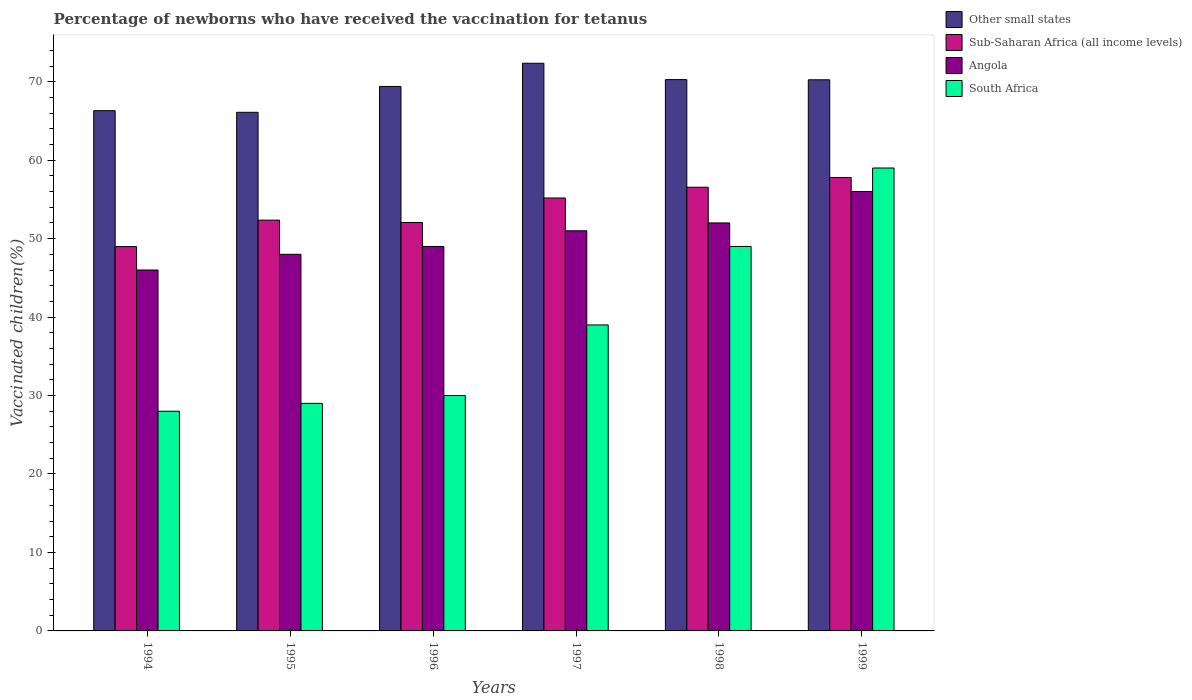How many bars are there on the 2nd tick from the right?
Offer a very short reply. 4. What is the label of the 3rd group of bars from the left?
Your answer should be very brief. 1996. In how many cases, is the number of bars for a given year not equal to the number of legend labels?
Offer a very short reply. 0. What is the percentage of vaccinated children in Sub-Saharan Africa (all income levels) in 1995?
Keep it short and to the point. 52.35. Across all years, what is the maximum percentage of vaccinated children in Angola?
Your response must be concise. 56. Across all years, what is the minimum percentage of vaccinated children in Sub-Saharan Africa (all income levels)?
Keep it short and to the point. 48.98. In which year was the percentage of vaccinated children in Other small states minimum?
Your answer should be compact. 1995. What is the total percentage of vaccinated children in South Africa in the graph?
Offer a very short reply. 234. What is the difference between the percentage of vaccinated children in Sub-Saharan Africa (all income levels) in 1996 and that in 1998?
Your answer should be compact. -4.5. What is the difference between the percentage of vaccinated children in South Africa in 1999 and the percentage of vaccinated children in Angola in 1995?
Your answer should be compact. 11. In the year 1996, what is the difference between the percentage of vaccinated children in South Africa and percentage of vaccinated children in Sub-Saharan Africa (all income levels)?
Offer a very short reply. -22.05. What is the ratio of the percentage of vaccinated children in South Africa in 1997 to that in 1999?
Your answer should be compact. 0.66. Is the difference between the percentage of vaccinated children in South Africa in 1997 and 1998 greater than the difference between the percentage of vaccinated children in Sub-Saharan Africa (all income levels) in 1997 and 1998?
Provide a succinct answer. No. What is the difference between the highest and the second highest percentage of vaccinated children in Other small states?
Offer a very short reply. 2.08. What is the difference between the highest and the lowest percentage of vaccinated children in Other small states?
Offer a very short reply. 6.25. Is the sum of the percentage of vaccinated children in Sub-Saharan Africa (all income levels) in 1998 and 1999 greater than the maximum percentage of vaccinated children in Other small states across all years?
Offer a very short reply. Yes. What does the 2nd bar from the left in 1995 represents?
Your answer should be very brief. Sub-Saharan Africa (all income levels). What does the 2nd bar from the right in 1998 represents?
Your response must be concise. Angola. Is it the case that in every year, the sum of the percentage of vaccinated children in South Africa and percentage of vaccinated children in Angola is greater than the percentage of vaccinated children in Sub-Saharan Africa (all income levels)?
Offer a very short reply. Yes. Does the graph contain any zero values?
Provide a succinct answer. No. Where does the legend appear in the graph?
Provide a succinct answer. Top right. What is the title of the graph?
Your answer should be very brief. Percentage of newborns who have received the vaccination for tetanus. Does "South Asia" appear as one of the legend labels in the graph?
Keep it short and to the point. No. What is the label or title of the X-axis?
Ensure brevity in your answer.  Years. What is the label or title of the Y-axis?
Your response must be concise. Vaccinated children(%). What is the Vaccinated children(%) of Other small states in 1994?
Give a very brief answer. 66.31. What is the Vaccinated children(%) of Sub-Saharan Africa (all income levels) in 1994?
Ensure brevity in your answer.  48.98. What is the Vaccinated children(%) of South Africa in 1994?
Your answer should be very brief. 28. What is the Vaccinated children(%) in Other small states in 1995?
Make the answer very short. 66.1. What is the Vaccinated children(%) in Sub-Saharan Africa (all income levels) in 1995?
Provide a short and direct response. 52.35. What is the Vaccinated children(%) in South Africa in 1995?
Your answer should be very brief. 29. What is the Vaccinated children(%) of Other small states in 1996?
Make the answer very short. 69.39. What is the Vaccinated children(%) of Sub-Saharan Africa (all income levels) in 1996?
Offer a terse response. 52.05. What is the Vaccinated children(%) in Angola in 1996?
Your answer should be very brief. 49. What is the Vaccinated children(%) of South Africa in 1996?
Make the answer very short. 30. What is the Vaccinated children(%) in Other small states in 1997?
Your answer should be compact. 72.35. What is the Vaccinated children(%) of Sub-Saharan Africa (all income levels) in 1997?
Ensure brevity in your answer.  55.18. What is the Vaccinated children(%) of Other small states in 1998?
Provide a short and direct response. 70.27. What is the Vaccinated children(%) in Sub-Saharan Africa (all income levels) in 1998?
Your answer should be compact. 56.55. What is the Vaccinated children(%) of South Africa in 1998?
Make the answer very short. 49. What is the Vaccinated children(%) of Other small states in 1999?
Your answer should be very brief. 70.24. What is the Vaccinated children(%) of Sub-Saharan Africa (all income levels) in 1999?
Your answer should be compact. 57.79. What is the Vaccinated children(%) in Angola in 1999?
Keep it short and to the point. 56. Across all years, what is the maximum Vaccinated children(%) of Other small states?
Provide a succinct answer. 72.35. Across all years, what is the maximum Vaccinated children(%) in Sub-Saharan Africa (all income levels)?
Provide a short and direct response. 57.79. Across all years, what is the maximum Vaccinated children(%) in Angola?
Give a very brief answer. 56. Across all years, what is the minimum Vaccinated children(%) in Other small states?
Provide a short and direct response. 66.1. Across all years, what is the minimum Vaccinated children(%) in Sub-Saharan Africa (all income levels)?
Provide a short and direct response. 48.98. Across all years, what is the minimum Vaccinated children(%) in Angola?
Give a very brief answer. 46. What is the total Vaccinated children(%) in Other small states in the graph?
Make the answer very short. 414.66. What is the total Vaccinated children(%) of Sub-Saharan Africa (all income levels) in the graph?
Give a very brief answer. 322.91. What is the total Vaccinated children(%) in Angola in the graph?
Keep it short and to the point. 302. What is the total Vaccinated children(%) in South Africa in the graph?
Make the answer very short. 234. What is the difference between the Vaccinated children(%) in Other small states in 1994 and that in 1995?
Your answer should be compact. 0.21. What is the difference between the Vaccinated children(%) in Sub-Saharan Africa (all income levels) in 1994 and that in 1995?
Give a very brief answer. -3.37. What is the difference between the Vaccinated children(%) of Angola in 1994 and that in 1995?
Offer a terse response. -2. What is the difference between the Vaccinated children(%) in South Africa in 1994 and that in 1995?
Offer a terse response. -1. What is the difference between the Vaccinated children(%) of Other small states in 1994 and that in 1996?
Make the answer very short. -3.08. What is the difference between the Vaccinated children(%) in Sub-Saharan Africa (all income levels) in 1994 and that in 1996?
Your answer should be compact. -3.07. What is the difference between the Vaccinated children(%) in South Africa in 1994 and that in 1996?
Provide a succinct answer. -2. What is the difference between the Vaccinated children(%) of Other small states in 1994 and that in 1997?
Provide a succinct answer. -6.04. What is the difference between the Vaccinated children(%) in Sub-Saharan Africa (all income levels) in 1994 and that in 1997?
Provide a succinct answer. -6.2. What is the difference between the Vaccinated children(%) in Other small states in 1994 and that in 1998?
Provide a short and direct response. -3.96. What is the difference between the Vaccinated children(%) in Sub-Saharan Africa (all income levels) in 1994 and that in 1998?
Your answer should be compact. -7.57. What is the difference between the Vaccinated children(%) in Angola in 1994 and that in 1998?
Offer a terse response. -6. What is the difference between the Vaccinated children(%) in South Africa in 1994 and that in 1998?
Give a very brief answer. -21. What is the difference between the Vaccinated children(%) in Other small states in 1994 and that in 1999?
Your answer should be very brief. -3.94. What is the difference between the Vaccinated children(%) in Sub-Saharan Africa (all income levels) in 1994 and that in 1999?
Provide a short and direct response. -8.81. What is the difference between the Vaccinated children(%) in Angola in 1994 and that in 1999?
Your answer should be compact. -10. What is the difference between the Vaccinated children(%) in South Africa in 1994 and that in 1999?
Offer a very short reply. -31. What is the difference between the Vaccinated children(%) in Other small states in 1995 and that in 1996?
Offer a terse response. -3.29. What is the difference between the Vaccinated children(%) of Sub-Saharan Africa (all income levels) in 1995 and that in 1996?
Keep it short and to the point. 0.3. What is the difference between the Vaccinated children(%) in Angola in 1995 and that in 1996?
Your answer should be compact. -1. What is the difference between the Vaccinated children(%) of South Africa in 1995 and that in 1996?
Keep it short and to the point. -1. What is the difference between the Vaccinated children(%) in Other small states in 1995 and that in 1997?
Your response must be concise. -6.25. What is the difference between the Vaccinated children(%) in Sub-Saharan Africa (all income levels) in 1995 and that in 1997?
Offer a terse response. -2.82. What is the difference between the Vaccinated children(%) in Angola in 1995 and that in 1997?
Keep it short and to the point. -3. What is the difference between the Vaccinated children(%) in Other small states in 1995 and that in 1998?
Offer a very short reply. -4.17. What is the difference between the Vaccinated children(%) in Sub-Saharan Africa (all income levels) in 1995 and that in 1998?
Give a very brief answer. -4.2. What is the difference between the Vaccinated children(%) of Angola in 1995 and that in 1998?
Your answer should be very brief. -4. What is the difference between the Vaccinated children(%) of South Africa in 1995 and that in 1998?
Your answer should be very brief. -20. What is the difference between the Vaccinated children(%) of Other small states in 1995 and that in 1999?
Provide a succinct answer. -4.14. What is the difference between the Vaccinated children(%) of Sub-Saharan Africa (all income levels) in 1995 and that in 1999?
Your answer should be compact. -5.44. What is the difference between the Vaccinated children(%) in Other small states in 1996 and that in 1997?
Give a very brief answer. -2.96. What is the difference between the Vaccinated children(%) of Sub-Saharan Africa (all income levels) in 1996 and that in 1997?
Provide a short and direct response. -3.12. What is the difference between the Vaccinated children(%) in Angola in 1996 and that in 1997?
Your response must be concise. -2. What is the difference between the Vaccinated children(%) in Other small states in 1996 and that in 1998?
Keep it short and to the point. -0.87. What is the difference between the Vaccinated children(%) of Sub-Saharan Africa (all income levels) in 1996 and that in 1998?
Offer a terse response. -4.5. What is the difference between the Vaccinated children(%) of Angola in 1996 and that in 1998?
Provide a short and direct response. -3. What is the difference between the Vaccinated children(%) in South Africa in 1996 and that in 1998?
Provide a short and direct response. -19. What is the difference between the Vaccinated children(%) of Other small states in 1996 and that in 1999?
Make the answer very short. -0.85. What is the difference between the Vaccinated children(%) of Sub-Saharan Africa (all income levels) in 1996 and that in 1999?
Ensure brevity in your answer.  -5.74. What is the difference between the Vaccinated children(%) of South Africa in 1996 and that in 1999?
Provide a succinct answer. -29. What is the difference between the Vaccinated children(%) in Other small states in 1997 and that in 1998?
Keep it short and to the point. 2.08. What is the difference between the Vaccinated children(%) in Sub-Saharan Africa (all income levels) in 1997 and that in 1998?
Offer a very short reply. -1.37. What is the difference between the Vaccinated children(%) in Angola in 1997 and that in 1998?
Keep it short and to the point. -1. What is the difference between the Vaccinated children(%) of South Africa in 1997 and that in 1998?
Keep it short and to the point. -10. What is the difference between the Vaccinated children(%) in Other small states in 1997 and that in 1999?
Provide a short and direct response. 2.11. What is the difference between the Vaccinated children(%) of Sub-Saharan Africa (all income levels) in 1997 and that in 1999?
Your answer should be very brief. -2.62. What is the difference between the Vaccinated children(%) in Angola in 1997 and that in 1999?
Your answer should be compact. -5. What is the difference between the Vaccinated children(%) in South Africa in 1997 and that in 1999?
Your answer should be very brief. -20. What is the difference between the Vaccinated children(%) in Other small states in 1998 and that in 1999?
Give a very brief answer. 0.02. What is the difference between the Vaccinated children(%) in Sub-Saharan Africa (all income levels) in 1998 and that in 1999?
Make the answer very short. -1.24. What is the difference between the Vaccinated children(%) of Angola in 1998 and that in 1999?
Keep it short and to the point. -4. What is the difference between the Vaccinated children(%) of South Africa in 1998 and that in 1999?
Provide a succinct answer. -10. What is the difference between the Vaccinated children(%) of Other small states in 1994 and the Vaccinated children(%) of Sub-Saharan Africa (all income levels) in 1995?
Provide a short and direct response. 13.96. What is the difference between the Vaccinated children(%) of Other small states in 1994 and the Vaccinated children(%) of Angola in 1995?
Your answer should be very brief. 18.31. What is the difference between the Vaccinated children(%) in Other small states in 1994 and the Vaccinated children(%) in South Africa in 1995?
Give a very brief answer. 37.31. What is the difference between the Vaccinated children(%) of Sub-Saharan Africa (all income levels) in 1994 and the Vaccinated children(%) of Angola in 1995?
Your answer should be very brief. 0.98. What is the difference between the Vaccinated children(%) in Sub-Saharan Africa (all income levels) in 1994 and the Vaccinated children(%) in South Africa in 1995?
Provide a short and direct response. 19.98. What is the difference between the Vaccinated children(%) in Angola in 1994 and the Vaccinated children(%) in South Africa in 1995?
Make the answer very short. 17. What is the difference between the Vaccinated children(%) of Other small states in 1994 and the Vaccinated children(%) of Sub-Saharan Africa (all income levels) in 1996?
Ensure brevity in your answer.  14.25. What is the difference between the Vaccinated children(%) in Other small states in 1994 and the Vaccinated children(%) in Angola in 1996?
Your answer should be compact. 17.31. What is the difference between the Vaccinated children(%) in Other small states in 1994 and the Vaccinated children(%) in South Africa in 1996?
Your response must be concise. 36.31. What is the difference between the Vaccinated children(%) in Sub-Saharan Africa (all income levels) in 1994 and the Vaccinated children(%) in Angola in 1996?
Ensure brevity in your answer.  -0.02. What is the difference between the Vaccinated children(%) in Sub-Saharan Africa (all income levels) in 1994 and the Vaccinated children(%) in South Africa in 1996?
Give a very brief answer. 18.98. What is the difference between the Vaccinated children(%) of Other small states in 1994 and the Vaccinated children(%) of Sub-Saharan Africa (all income levels) in 1997?
Your response must be concise. 11.13. What is the difference between the Vaccinated children(%) in Other small states in 1994 and the Vaccinated children(%) in Angola in 1997?
Your answer should be compact. 15.31. What is the difference between the Vaccinated children(%) in Other small states in 1994 and the Vaccinated children(%) in South Africa in 1997?
Ensure brevity in your answer.  27.31. What is the difference between the Vaccinated children(%) in Sub-Saharan Africa (all income levels) in 1994 and the Vaccinated children(%) in Angola in 1997?
Give a very brief answer. -2.02. What is the difference between the Vaccinated children(%) in Sub-Saharan Africa (all income levels) in 1994 and the Vaccinated children(%) in South Africa in 1997?
Provide a succinct answer. 9.98. What is the difference between the Vaccinated children(%) in Other small states in 1994 and the Vaccinated children(%) in Sub-Saharan Africa (all income levels) in 1998?
Offer a terse response. 9.76. What is the difference between the Vaccinated children(%) of Other small states in 1994 and the Vaccinated children(%) of Angola in 1998?
Ensure brevity in your answer.  14.31. What is the difference between the Vaccinated children(%) in Other small states in 1994 and the Vaccinated children(%) in South Africa in 1998?
Provide a short and direct response. 17.31. What is the difference between the Vaccinated children(%) in Sub-Saharan Africa (all income levels) in 1994 and the Vaccinated children(%) in Angola in 1998?
Make the answer very short. -3.02. What is the difference between the Vaccinated children(%) in Sub-Saharan Africa (all income levels) in 1994 and the Vaccinated children(%) in South Africa in 1998?
Provide a succinct answer. -0.02. What is the difference between the Vaccinated children(%) in Other small states in 1994 and the Vaccinated children(%) in Sub-Saharan Africa (all income levels) in 1999?
Provide a short and direct response. 8.52. What is the difference between the Vaccinated children(%) in Other small states in 1994 and the Vaccinated children(%) in Angola in 1999?
Offer a terse response. 10.31. What is the difference between the Vaccinated children(%) of Other small states in 1994 and the Vaccinated children(%) of South Africa in 1999?
Offer a terse response. 7.31. What is the difference between the Vaccinated children(%) of Sub-Saharan Africa (all income levels) in 1994 and the Vaccinated children(%) of Angola in 1999?
Provide a succinct answer. -7.02. What is the difference between the Vaccinated children(%) of Sub-Saharan Africa (all income levels) in 1994 and the Vaccinated children(%) of South Africa in 1999?
Offer a very short reply. -10.02. What is the difference between the Vaccinated children(%) of Other small states in 1995 and the Vaccinated children(%) of Sub-Saharan Africa (all income levels) in 1996?
Your answer should be compact. 14.04. What is the difference between the Vaccinated children(%) in Other small states in 1995 and the Vaccinated children(%) in Angola in 1996?
Your answer should be very brief. 17.1. What is the difference between the Vaccinated children(%) of Other small states in 1995 and the Vaccinated children(%) of South Africa in 1996?
Your answer should be compact. 36.1. What is the difference between the Vaccinated children(%) of Sub-Saharan Africa (all income levels) in 1995 and the Vaccinated children(%) of Angola in 1996?
Keep it short and to the point. 3.35. What is the difference between the Vaccinated children(%) in Sub-Saharan Africa (all income levels) in 1995 and the Vaccinated children(%) in South Africa in 1996?
Make the answer very short. 22.35. What is the difference between the Vaccinated children(%) of Angola in 1995 and the Vaccinated children(%) of South Africa in 1996?
Your response must be concise. 18. What is the difference between the Vaccinated children(%) of Other small states in 1995 and the Vaccinated children(%) of Sub-Saharan Africa (all income levels) in 1997?
Keep it short and to the point. 10.92. What is the difference between the Vaccinated children(%) in Other small states in 1995 and the Vaccinated children(%) in Angola in 1997?
Ensure brevity in your answer.  15.1. What is the difference between the Vaccinated children(%) in Other small states in 1995 and the Vaccinated children(%) in South Africa in 1997?
Give a very brief answer. 27.1. What is the difference between the Vaccinated children(%) in Sub-Saharan Africa (all income levels) in 1995 and the Vaccinated children(%) in Angola in 1997?
Provide a short and direct response. 1.35. What is the difference between the Vaccinated children(%) in Sub-Saharan Africa (all income levels) in 1995 and the Vaccinated children(%) in South Africa in 1997?
Keep it short and to the point. 13.35. What is the difference between the Vaccinated children(%) in Other small states in 1995 and the Vaccinated children(%) in Sub-Saharan Africa (all income levels) in 1998?
Keep it short and to the point. 9.55. What is the difference between the Vaccinated children(%) in Other small states in 1995 and the Vaccinated children(%) in Angola in 1998?
Provide a short and direct response. 14.1. What is the difference between the Vaccinated children(%) in Other small states in 1995 and the Vaccinated children(%) in South Africa in 1998?
Ensure brevity in your answer.  17.1. What is the difference between the Vaccinated children(%) of Sub-Saharan Africa (all income levels) in 1995 and the Vaccinated children(%) of Angola in 1998?
Your answer should be very brief. 0.35. What is the difference between the Vaccinated children(%) of Sub-Saharan Africa (all income levels) in 1995 and the Vaccinated children(%) of South Africa in 1998?
Your answer should be very brief. 3.35. What is the difference between the Vaccinated children(%) in Angola in 1995 and the Vaccinated children(%) in South Africa in 1998?
Keep it short and to the point. -1. What is the difference between the Vaccinated children(%) of Other small states in 1995 and the Vaccinated children(%) of Sub-Saharan Africa (all income levels) in 1999?
Make the answer very short. 8.31. What is the difference between the Vaccinated children(%) of Other small states in 1995 and the Vaccinated children(%) of Angola in 1999?
Offer a terse response. 10.1. What is the difference between the Vaccinated children(%) in Other small states in 1995 and the Vaccinated children(%) in South Africa in 1999?
Provide a succinct answer. 7.1. What is the difference between the Vaccinated children(%) in Sub-Saharan Africa (all income levels) in 1995 and the Vaccinated children(%) in Angola in 1999?
Provide a succinct answer. -3.65. What is the difference between the Vaccinated children(%) in Sub-Saharan Africa (all income levels) in 1995 and the Vaccinated children(%) in South Africa in 1999?
Offer a very short reply. -6.65. What is the difference between the Vaccinated children(%) in Angola in 1995 and the Vaccinated children(%) in South Africa in 1999?
Offer a very short reply. -11. What is the difference between the Vaccinated children(%) in Other small states in 1996 and the Vaccinated children(%) in Sub-Saharan Africa (all income levels) in 1997?
Provide a succinct answer. 14.21. What is the difference between the Vaccinated children(%) in Other small states in 1996 and the Vaccinated children(%) in Angola in 1997?
Your response must be concise. 18.39. What is the difference between the Vaccinated children(%) of Other small states in 1996 and the Vaccinated children(%) of South Africa in 1997?
Your answer should be compact. 30.39. What is the difference between the Vaccinated children(%) in Sub-Saharan Africa (all income levels) in 1996 and the Vaccinated children(%) in Angola in 1997?
Your answer should be compact. 1.05. What is the difference between the Vaccinated children(%) of Sub-Saharan Africa (all income levels) in 1996 and the Vaccinated children(%) of South Africa in 1997?
Your response must be concise. 13.05. What is the difference between the Vaccinated children(%) of Angola in 1996 and the Vaccinated children(%) of South Africa in 1997?
Give a very brief answer. 10. What is the difference between the Vaccinated children(%) of Other small states in 1996 and the Vaccinated children(%) of Sub-Saharan Africa (all income levels) in 1998?
Offer a very short reply. 12.84. What is the difference between the Vaccinated children(%) in Other small states in 1996 and the Vaccinated children(%) in Angola in 1998?
Provide a succinct answer. 17.39. What is the difference between the Vaccinated children(%) in Other small states in 1996 and the Vaccinated children(%) in South Africa in 1998?
Keep it short and to the point. 20.39. What is the difference between the Vaccinated children(%) of Sub-Saharan Africa (all income levels) in 1996 and the Vaccinated children(%) of Angola in 1998?
Ensure brevity in your answer.  0.05. What is the difference between the Vaccinated children(%) in Sub-Saharan Africa (all income levels) in 1996 and the Vaccinated children(%) in South Africa in 1998?
Provide a short and direct response. 3.05. What is the difference between the Vaccinated children(%) in Other small states in 1996 and the Vaccinated children(%) in Sub-Saharan Africa (all income levels) in 1999?
Keep it short and to the point. 11.6. What is the difference between the Vaccinated children(%) in Other small states in 1996 and the Vaccinated children(%) in Angola in 1999?
Make the answer very short. 13.39. What is the difference between the Vaccinated children(%) of Other small states in 1996 and the Vaccinated children(%) of South Africa in 1999?
Your answer should be very brief. 10.39. What is the difference between the Vaccinated children(%) in Sub-Saharan Africa (all income levels) in 1996 and the Vaccinated children(%) in Angola in 1999?
Offer a very short reply. -3.95. What is the difference between the Vaccinated children(%) in Sub-Saharan Africa (all income levels) in 1996 and the Vaccinated children(%) in South Africa in 1999?
Make the answer very short. -6.95. What is the difference between the Vaccinated children(%) in Other small states in 1997 and the Vaccinated children(%) in Sub-Saharan Africa (all income levels) in 1998?
Give a very brief answer. 15.8. What is the difference between the Vaccinated children(%) in Other small states in 1997 and the Vaccinated children(%) in Angola in 1998?
Offer a terse response. 20.35. What is the difference between the Vaccinated children(%) in Other small states in 1997 and the Vaccinated children(%) in South Africa in 1998?
Make the answer very short. 23.35. What is the difference between the Vaccinated children(%) of Sub-Saharan Africa (all income levels) in 1997 and the Vaccinated children(%) of Angola in 1998?
Ensure brevity in your answer.  3.18. What is the difference between the Vaccinated children(%) in Sub-Saharan Africa (all income levels) in 1997 and the Vaccinated children(%) in South Africa in 1998?
Keep it short and to the point. 6.18. What is the difference between the Vaccinated children(%) of Angola in 1997 and the Vaccinated children(%) of South Africa in 1998?
Keep it short and to the point. 2. What is the difference between the Vaccinated children(%) of Other small states in 1997 and the Vaccinated children(%) of Sub-Saharan Africa (all income levels) in 1999?
Keep it short and to the point. 14.56. What is the difference between the Vaccinated children(%) of Other small states in 1997 and the Vaccinated children(%) of Angola in 1999?
Offer a terse response. 16.35. What is the difference between the Vaccinated children(%) in Other small states in 1997 and the Vaccinated children(%) in South Africa in 1999?
Ensure brevity in your answer.  13.35. What is the difference between the Vaccinated children(%) in Sub-Saharan Africa (all income levels) in 1997 and the Vaccinated children(%) in Angola in 1999?
Make the answer very short. -0.82. What is the difference between the Vaccinated children(%) in Sub-Saharan Africa (all income levels) in 1997 and the Vaccinated children(%) in South Africa in 1999?
Provide a succinct answer. -3.82. What is the difference between the Vaccinated children(%) of Angola in 1997 and the Vaccinated children(%) of South Africa in 1999?
Your answer should be compact. -8. What is the difference between the Vaccinated children(%) of Other small states in 1998 and the Vaccinated children(%) of Sub-Saharan Africa (all income levels) in 1999?
Your answer should be compact. 12.47. What is the difference between the Vaccinated children(%) in Other small states in 1998 and the Vaccinated children(%) in Angola in 1999?
Provide a short and direct response. 14.27. What is the difference between the Vaccinated children(%) of Other small states in 1998 and the Vaccinated children(%) of South Africa in 1999?
Give a very brief answer. 11.27. What is the difference between the Vaccinated children(%) of Sub-Saharan Africa (all income levels) in 1998 and the Vaccinated children(%) of Angola in 1999?
Make the answer very short. 0.55. What is the difference between the Vaccinated children(%) of Sub-Saharan Africa (all income levels) in 1998 and the Vaccinated children(%) of South Africa in 1999?
Your response must be concise. -2.45. What is the average Vaccinated children(%) in Other small states per year?
Ensure brevity in your answer.  69.11. What is the average Vaccinated children(%) in Sub-Saharan Africa (all income levels) per year?
Provide a short and direct response. 53.82. What is the average Vaccinated children(%) of Angola per year?
Provide a succinct answer. 50.33. What is the average Vaccinated children(%) in South Africa per year?
Keep it short and to the point. 39. In the year 1994, what is the difference between the Vaccinated children(%) of Other small states and Vaccinated children(%) of Sub-Saharan Africa (all income levels)?
Offer a very short reply. 17.33. In the year 1994, what is the difference between the Vaccinated children(%) of Other small states and Vaccinated children(%) of Angola?
Give a very brief answer. 20.31. In the year 1994, what is the difference between the Vaccinated children(%) in Other small states and Vaccinated children(%) in South Africa?
Make the answer very short. 38.31. In the year 1994, what is the difference between the Vaccinated children(%) in Sub-Saharan Africa (all income levels) and Vaccinated children(%) in Angola?
Your answer should be compact. 2.98. In the year 1994, what is the difference between the Vaccinated children(%) of Sub-Saharan Africa (all income levels) and Vaccinated children(%) of South Africa?
Your answer should be compact. 20.98. In the year 1994, what is the difference between the Vaccinated children(%) in Angola and Vaccinated children(%) in South Africa?
Offer a terse response. 18. In the year 1995, what is the difference between the Vaccinated children(%) of Other small states and Vaccinated children(%) of Sub-Saharan Africa (all income levels)?
Offer a very short reply. 13.75. In the year 1995, what is the difference between the Vaccinated children(%) of Other small states and Vaccinated children(%) of Angola?
Ensure brevity in your answer.  18.1. In the year 1995, what is the difference between the Vaccinated children(%) in Other small states and Vaccinated children(%) in South Africa?
Your answer should be very brief. 37.1. In the year 1995, what is the difference between the Vaccinated children(%) in Sub-Saharan Africa (all income levels) and Vaccinated children(%) in Angola?
Offer a terse response. 4.35. In the year 1995, what is the difference between the Vaccinated children(%) in Sub-Saharan Africa (all income levels) and Vaccinated children(%) in South Africa?
Provide a short and direct response. 23.35. In the year 1996, what is the difference between the Vaccinated children(%) in Other small states and Vaccinated children(%) in Sub-Saharan Africa (all income levels)?
Provide a succinct answer. 17.34. In the year 1996, what is the difference between the Vaccinated children(%) of Other small states and Vaccinated children(%) of Angola?
Your answer should be compact. 20.39. In the year 1996, what is the difference between the Vaccinated children(%) of Other small states and Vaccinated children(%) of South Africa?
Ensure brevity in your answer.  39.39. In the year 1996, what is the difference between the Vaccinated children(%) in Sub-Saharan Africa (all income levels) and Vaccinated children(%) in Angola?
Provide a succinct answer. 3.05. In the year 1996, what is the difference between the Vaccinated children(%) in Sub-Saharan Africa (all income levels) and Vaccinated children(%) in South Africa?
Keep it short and to the point. 22.05. In the year 1997, what is the difference between the Vaccinated children(%) of Other small states and Vaccinated children(%) of Sub-Saharan Africa (all income levels)?
Keep it short and to the point. 17.17. In the year 1997, what is the difference between the Vaccinated children(%) in Other small states and Vaccinated children(%) in Angola?
Your answer should be very brief. 21.35. In the year 1997, what is the difference between the Vaccinated children(%) in Other small states and Vaccinated children(%) in South Africa?
Your response must be concise. 33.35. In the year 1997, what is the difference between the Vaccinated children(%) of Sub-Saharan Africa (all income levels) and Vaccinated children(%) of Angola?
Ensure brevity in your answer.  4.18. In the year 1997, what is the difference between the Vaccinated children(%) of Sub-Saharan Africa (all income levels) and Vaccinated children(%) of South Africa?
Your answer should be very brief. 16.18. In the year 1998, what is the difference between the Vaccinated children(%) in Other small states and Vaccinated children(%) in Sub-Saharan Africa (all income levels)?
Keep it short and to the point. 13.72. In the year 1998, what is the difference between the Vaccinated children(%) of Other small states and Vaccinated children(%) of Angola?
Give a very brief answer. 18.27. In the year 1998, what is the difference between the Vaccinated children(%) in Other small states and Vaccinated children(%) in South Africa?
Provide a succinct answer. 21.27. In the year 1998, what is the difference between the Vaccinated children(%) of Sub-Saharan Africa (all income levels) and Vaccinated children(%) of Angola?
Offer a terse response. 4.55. In the year 1998, what is the difference between the Vaccinated children(%) in Sub-Saharan Africa (all income levels) and Vaccinated children(%) in South Africa?
Provide a short and direct response. 7.55. In the year 1998, what is the difference between the Vaccinated children(%) of Angola and Vaccinated children(%) of South Africa?
Your answer should be very brief. 3. In the year 1999, what is the difference between the Vaccinated children(%) in Other small states and Vaccinated children(%) in Sub-Saharan Africa (all income levels)?
Offer a terse response. 12.45. In the year 1999, what is the difference between the Vaccinated children(%) of Other small states and Vaccinated children(%) of Angola?
Your response must be concise. 14.24. In the year 1999, what is the difference between the Vaccinated children(%) in Other small states and Vaccinated children(%) in South Africa?
Provide a short and direct response. 11.24. In the year 1999, what is the difference between the Vaccinated children(%) of Sub-Saharan Africa (all income levels) and Vaccinated children(%) of Angola?
Give a very brief answer. 1.79. In the year 1999, what is the difference between the Vaccinated children(%) of Sub-Saharan Africa (all income levels) and Vaccinated children(%) of South Africa?
Your response must be concise. -1.21. In the year 1999, what is the difference between the Vaccinated children(%) of Angola and Vaccinated children(%) of South Africa?
Offer a terse response. -3. What is the ratio of the Vaccinated children(%) in Other small states in 1994 to that in 1995?
Offer a terse response. 1. What is the ratio of the Vaccinated children(%) of Sub-Saharan Africa (all income levels) in 1994 to that in 1995?
Your answer should be very brief. 0.94. What is the ratio of the Vaccinated children(%) in South Africa in 1994 to that in 1995?
Ensure brevity in your answer.  0.97. What is the ratio of the Vaccinated children(%) of Other small states in 1994 to that in 1996?
Your answer should be very brief. 0.96. What is the ratio of the Vaccinated children(%) of Sub-Saharan Africa (all income levels) in 1994 to that in 1996?
Make the answer very short. 0.94. What is the ratio of the Vaccinated children(%) of Angola in 1994 to that in 1996?
Make the answer very short. 0.94. What is the ratio of the Vaccinated children(%) of Other small states in 1994 to that in 1997?
Offer a very short reply. 0.92. What is the ratio of the Vaccinated children(%) of Sub-Saharan Africa (all income levels) in 1994 to that in 1997?
Make the answer very short. 0.89. What is the ratio of the Vaccinated children(%) in Angola in 1994 to that in 1997?
Provide a short and direct response. 0.9. What is the ratio of the Vaccinated children(%) in South Africa in 1994 to that in 1997?
Give a very brief answer. 0.72. What is the ratio of the Vaccinated children(%) of Other small states in 1994 to that in 1998?
Keep it short and to the point. 0.94. What is the ratio of the Vaccinated children(%) in Sub-Saharan Africa (all income levels) in 1994 to that in 1998?
Your answer should be compact. 0.87. What is the ratio of the Vaccinated children(%) in Angola in 1994 to that in 1998?
Ensure brevity in your answer.  0.88. What is the ratio of the Vaccinated children(%) in Other small states in 1994 to that in 1999?
Give a very brief answer. 0.94. What is the ratio of the Vaccinated children(%) of Sub-Saharan Africa (all income levels) in 1994 to that in 1999?
Your response must be concise. 0.85. What is the ratio of the Vaccinated children(%) in Angola in 1994 to that in 1999?
Give a very brief answer. 0.82. What is the ratio of the Vaccinated children(%) in South Africa in 1994 to that in 1999?
Keep it short and to the point. 0.47. What is the ratio of the Vaccinated children(%) of Other small states in 1995 to that in 1996?
Offer a terse response. 0.95. What is the ratio of the Vaccinated children(%) in Angola in 1995 to that in 1996?
Your answer should be compact. 0.98. What is the ratio of the Vaccinated children(%) in South Africa in 1995 to that in 1996?
Make the answer very short. 0.97. What is the ratio of the Vaccinated children(%) in Other small states in 1995 to that in 1997?
Your response must be concise. 0.91. What is the ratio of the Vaccinated children(%) of Sub-Saharan Africa (all income levels) in 1995 to that in 1997?
Offer a very short reply. 0.95. What is the ratio of the Vaccinated children(%) in South Africa in 1995 to that in 1997?
Make the answer very short. 0.74. What is the ratio of the Vaccinated children(%) in Other small states in 1995 to that in 1998?
Your response must be concise. 0.94. What is the ratio of the Vaccinated children(%) of Sub-Saharan Africa (all income levels) in 1995 to that in 1998?
Provide a short and direct response. 0.93. What is the ratio of the Vaccinated children(%) in Angola in 1995 to that in 1998?
Your response must be concise. 0.92. What is the ratio of the Vaccinated children(%) of South Africa in 1995 to that in 1998?
Your answer should be very brief. 0.59. What is the ratio of the Vaccinated children(%) of Other small states in 1995 to that in 1999?
Give a very brief answer. 0.94. What is the ratio of the Vaccinated children(%) of Sub-Saharan Africa (all income levels) in 1995 to that in 1999?
Ensure brevity in your answer.  0.91. What is the ratio of the Vaccinated children(%) of South Africa in 1995 to that in 1999?
Offer a very short reply. 0.49. What is the ratio of the Vaccinated children(%) in Other small states in 1996 to that in 1997?
Keep it short and to the point. 0.96. What is the ratio of the Vaccinated children(%) in Sub-Saharan Africa (all income levels) in 1996 to that in 1997?
Provide a short and direct response. 0.94. What is the ratio of the Vaccinated children(%) of Angola in 1996 to that in 1997?
Make the answer very short. 0.96. What is the ratio of the Vaccinated children(%) of South Africa in 1996 to that in 1997?
Offer a terse response. 0.77. What is the ratio of the Vaccinated children(%) of Other small states in 1996 to that in 1998?
Your answer should be compact. 0.99. What is the ratio of the Vaccinated children(%) of Sub-Saharan Africa (all income levels) in 1996 to that in 1998?
Provide a short and direct response. 0.92. What is the ratio of the Vaccinated children(%) of Angola in 1996 to that in 1998?
Provide a short and direct response. 0.94. What is the ratio of the Vaccinated children(%) in South Africa in 1996 to that in 1998?
Your answer should be very brief. 0.61. What is the ratio of the Vaccinated children(%) of Other small states in 1996 to that in 1999?
Keep it short and to the point. 0.99. What is the ratio of the Vaccinated children(%) in Sub-Saharan Africa (all income levels) in 1996 to that in 1999?
Your answer should be very brief. 0.9. What is the ratio of the Vaccinated children(%) in Angola in 1996 to that in 1999?
Your response must be concise. 0.88. What is the ratio of the Vaccinated children(%) of South Africa in 1996 to that in 1999?
Offer a terse response. 0.51. What is the ratio of the Vaccinated children(%) of Other small states in 1997 to that in 1998?
Provide a succinct answer. 1.03. What is the ratio of the Vaccinated children(%) in Sub-Saharan Africa (all income levels) in 1997 to that in 1998?
Your answer should be very brief. 0.98. What is the ratio of the Vaccinated children(%) in Angola in 1997 to that in 1998?
Offer a terse response. 0.98. What is the ratio of the Vaccinated children(%) of South Africa in 1997 to that in 1998?
Your answer should be compact. 0.8. What is the ratio of the Vaccinated children(%) of Other small states in 1997 to that in 1999?
Provide a short and direct response. 1.03. What is the ratio of the Vaccinated children(%) in Sub-Saharan Africa (all income levels) in 1997 to that in 1999?
Provide a succinct answer. 0.95. What is the ratio of the Vaccinated children(%) of Angola in 1997 to that in 1999?
Give a very brief answer. 0.91. What is the ratio of the Vaccinated children(%) in South Africa in 1997 to that in 1999?
Your answer should be compact. 0.66. What is the ratio of the Vaccinated children(%) of Sub-Saharan Africa (all income levels) in 1998 to that in 1999?
Provide a short and direct response. 0.98. What is the ratio of the Vaccinated children(%) of Angola in 1998 to that in 1999?
Provide a short and direct response. 0.93. What is the ratio of the Vaccinated children(%) of South Africa in 1998 to that in 1999?
Your answer should be very brief. 0.83. What is the difference between the highest and the second highest Vaccinated children(%) of Other small states?
Give a very brief answer. 2.08. What is the difference between the highest and the second highest Vaccinated children(%) in Sub-Saharan Africa (all income levels)?
Provide a short and direct response. 1.24. What is the difference between the highest and the second highest Vaccinated children(%) in South Africa?
Keep it short and to the point. 10. What is the difference between the highest and the lowest Vaccinated children(%) in Other small states?
Offer a terse response. 6.25. What is the difference between the highest and the lowest Vaccinated children(%) in Sub-Saharan Africa (all income levels)?
Provide a succinct answer. 8.81. What is the difference between the highest and the lowest Vaccinated children(%) of Angola?
Offer a terse response. 10. What is the difference between the highest and the lowest Vaccinated children(%) of South Africa?
Keep it short and to the point. 31. 